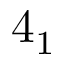<formula> <loc_0><loc_0><loc_500><loc_500>4 _ { 1 }</formula> 